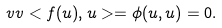Convert formula to latex. <formula><loc_0><loc_0><loc_500><loc_500>\ v v < f ( u ) , u > = \phi ( u , u ) = 0 .</formula> 